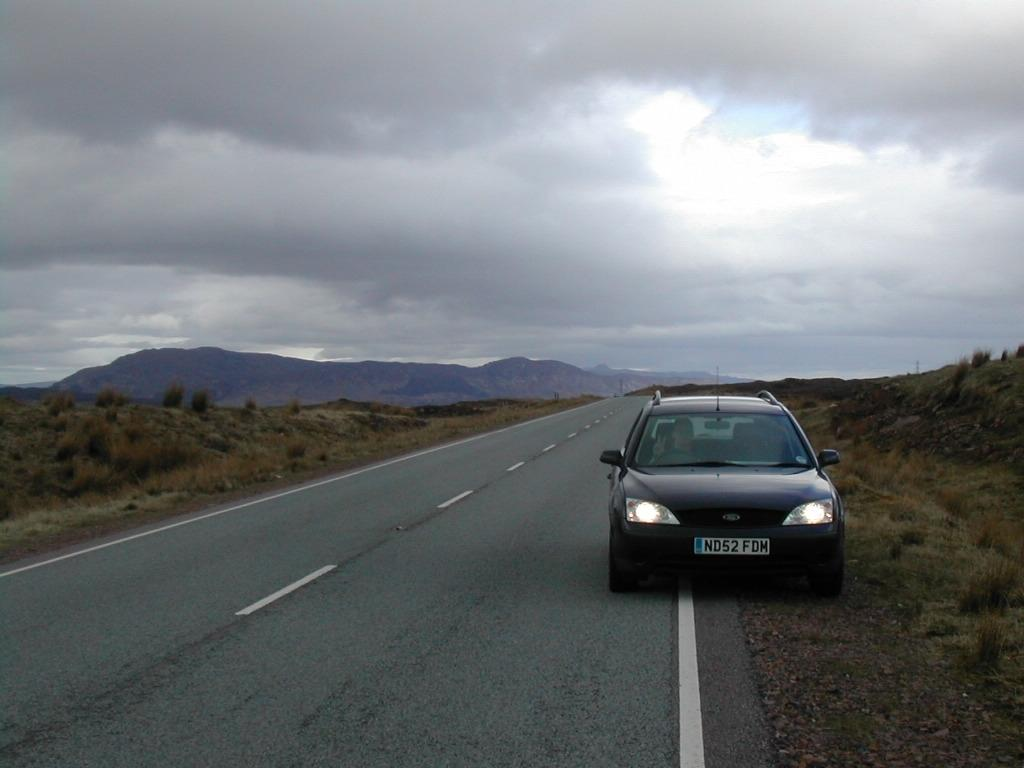What is the main feature of the image? There is a road in the image. What else can be seen near the road? There is a car on the side of the road and plants on the sides of the road. What can be seen in the distance in the image? There are hills visible in the background of the image. What is visible above the hills in the image? The sky is visible in the background of the image, and clouds are present in the sky. What type of pollution can be seen coming from the car in the image? There is no indication of pollution in the image; it only shows a car on the side of the road. How much zinc is present in the plants on the sides of the road? There is no information about the chemical composition of the plants in the image, so it is impossible to determine the amount of zinc present. 